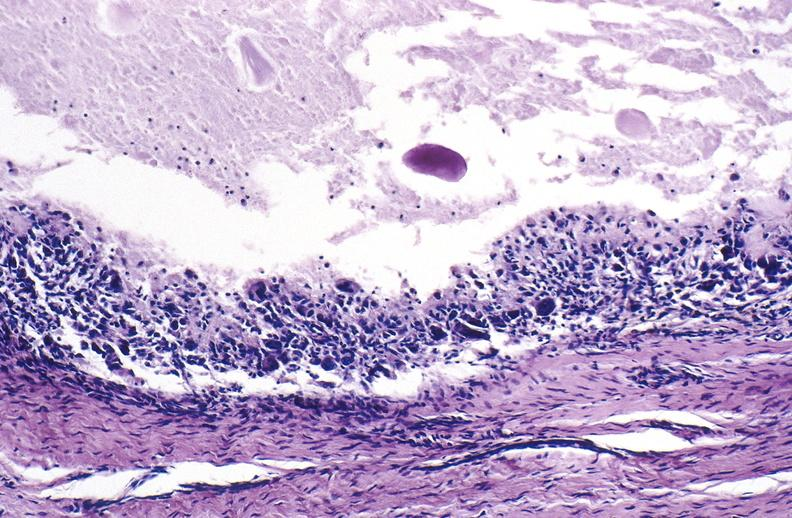what does this image show?
Answer the question using a single word or phrase. Gout 